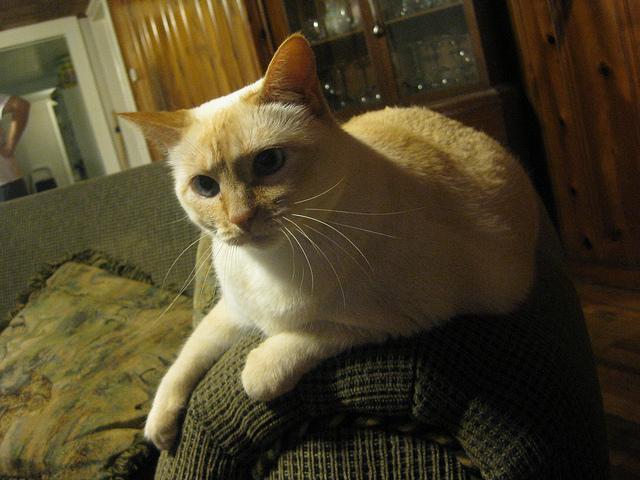What type of cat is this?
Make your selection from the four choices given to correctly answer the question.
Options: Long hair, siamese, short hair, sphynx. Short hair. 